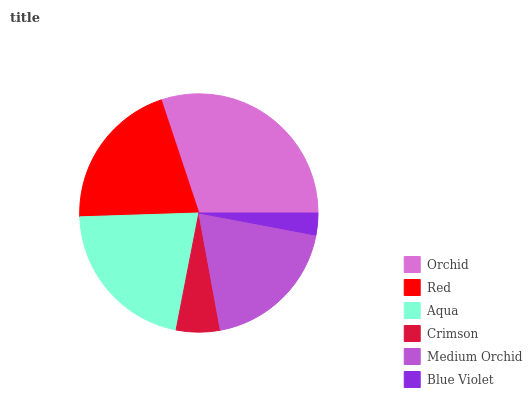Is Blue Violet the minimum?
Answer yes or no. Yes. Is Orchid the maximum?
Answer yes or no. Yes. Is Red the minimum?
Answer yes or no. No. Is Red the maximum?
Answer yes or no. No. Is Orchid greater than Red?
Answer yes or no. Yes. Is Red less than Orchid?
Answer yes or no. Yes. Is Red greater than Orchid?
Answer yes or no. No. Is Orchid less than Red?
Answer yes or no. No. Is Red the high median?
Answer yes or no. Yes. Is Medium Orchid the low median?
Answer yes or no. Yes. Is Medium Orchid the high median?
Answer yes or no. No. Is Aqua the low median?
Answer yes or no. No. 